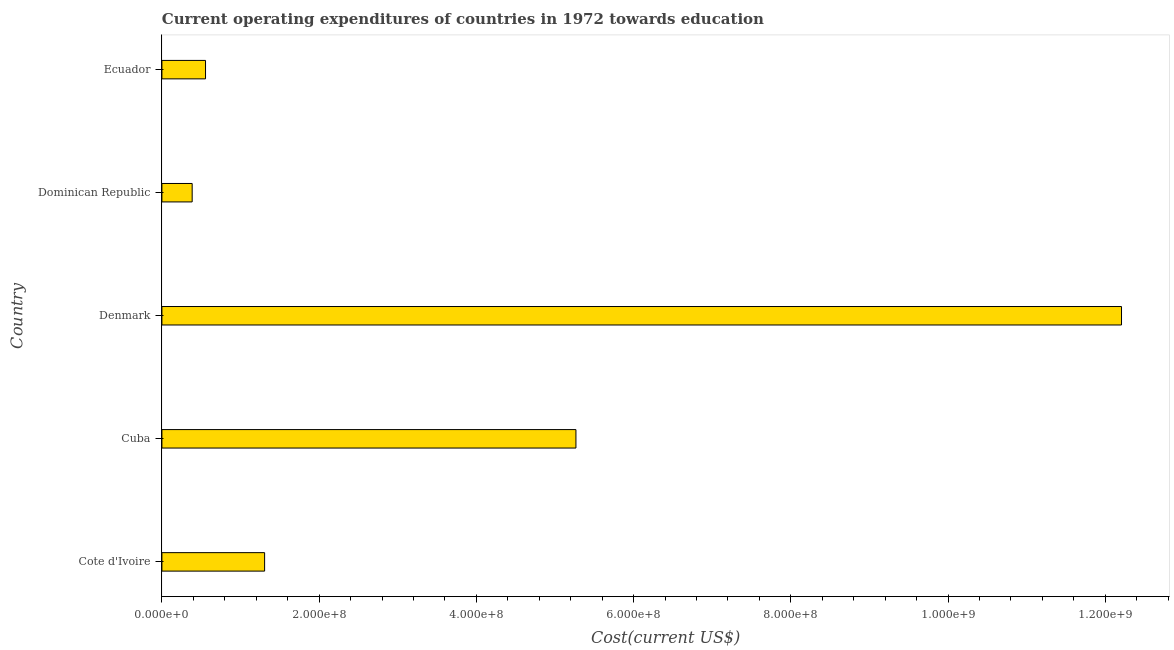What is the title of the graph?
Offer a terse response. Current operating expenditures of countries in 1972 towards education. What is the label or title of the X-axis?
Offer a very short reply. Cost(current US$). What is the education expenditure in Denmark?
Offer a terse response. 1.22e+09. Across all countries, what is the maximum education expenditure?
Your answer should be compact. 1.22e+09. Across all countries, what is the minimum education expenditure?
Give a very brief answer. 3.85e+07. In which country was the education expenditure minimum?
Give a very brief answer. Dominican Republic. What is the sum of the education expenditure?
Your answer should be very brief. 1.97e+09. What is the difference between the education expenditure in Cote d'Ivoire and Ecuador?
Provide a succinct answer. 7.51e+07. What is the average education expenditure per country?
Make the answer very short. 3.94e+08. What is the median education expenditure?
Your response must be concise. 1.31e+08. In how many countries, is the education expenditure greater than 520000000 US$?
Keep it short and to the point. 2. What is the ratio of the education expenditure in Cote d'Ivoire to that in Ecuador?
Keep it short and to the point. 2.35. What is the difference between the highest and the second highest education expenditure?
Keep it short and to the point. 6.94e+08. Is the sum of the education expenditure in Dominican Republic and Ecuador greater than the maximum education expenditure across all countries?
Ensure brevity in your answer.  No. What is the difference between the highest and the lowest education expenditure?
Your answer should be compact. 1.18e+09. In how many countries, is the education expenditure greater than the average education expenditure taken over all countries?
Make the answer very short. 2. What is the Cost(current US$) of Cote d'Ivoire?
Your answer should be compact. 1.31e+08. What is the Cost(current US$) of Cuba?
Provide a short and direct response. 5.27e+08. What is the Cost(current US$) in Denmark?
Make the answer very short. 1.22e+09. What is the Cost(current US$) of Dominican Republic?
Your response must be concise. 3.85e+07. What is the Cost(current US$) in Ecuador?
Provide a succinct answer. 5.55e+07. What is the difference between the Cost(current US$) in Cote d'Ivoire and Cuba?
Ensure brevity in your answer.  -3.96e+08. What is the difference between the Cost(current US$) in Cote d'Ivoire and Denmark?
Your answer should be compact. -1.09e+09. What is the difference between the Cost(current US$) in Cote d'Ivoire and Dominican Republic?
Offer a very short reply. 9.21e+07. What is the difference between the Cost(current US$) in Cote d'Ivoire and Ecuador?
Provide a succinct answer. 7.51e+07. What is the difference between the Cost(current US$) in Cuba and Denmark?
Your response must be concise. -6.94e+08. What is the difference between the Cost(current US$) in Cuba and Dominican Republic?
Offer a terse response. 4.88e+08. What is the difference between the Cost(current US$) in Cuba and Ecuador?
Offer a very short reply. 4.71e+08. What is the difference between the Cost(current US$) in Denmark and Dominican Republic?
Provide a succinct answer. 1.18e+09. What is the difference between the Cost(current US$) in Denmark and Ecuador?
Your answer should be very brief. 1.17e+09. What is the difference between the Cost(current US$) in Dominican Republic and Ecuador?
Your response must be concise. -1.70e+07. What is the ratio of the Cost(current US$) in Cote d'Ivoire to that in Cuba?
Offer a very short reply. 0.25. What is the ratio of the Cost(current US$) in Cote d'Ivoire to that in Denmark?
Offer a very short reply. 0.11. What is the ratio of the Cost(current US$) in Cote d'Ivoire to that in Dominican Republic?
Provide a short and direct response. 3.39. What is the ratio of the Cost(current US$) in Cote d'Ivoire to that in Ecuador?
Your answer should be very brief. 2.35. What is the ratio of the Cost(current US$) in Cuba to that in Denmark?
Provide a succinct answer. 0.43. What is the ratio of the Cost(current US$) in Cuba to that in Dominican Republic?
Give a very brief answer. 13.67. What is the ratio of the Cost(current US$) in Cuba to that in Ecuador?
Make the answer very short. 9.49. What is the ratio of the Cost(current US$) in Denmark to that in Dominican Republic?
Make the answer very short. 31.69. What is the ratio of the Cost(current US$) in Denmark to that in Ecuador?
Ensure brevity in your answer.  22. What is the ratio of the Cost(current US$) in Dominican Republic to that in Ecuador?
Offer a terse response. 0.69. 